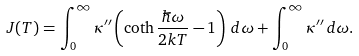<formula> <loc_0><loc_0><loc_500><loc_500>J ( T ) = \int _ { 0 } ^ { \infty } \kappa ^ { \prime \prime } \left ( \coth \frac { \hbar { \omega } } { 2 k T } - 1 \right ) \, d \omega + \int _ { 0 } ^ { \infty } \kappa ^ { \prime \prime } \, d \omega .</formula> 